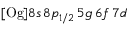Convert formula to latex. <formula><loc_0><loc_0><loc_500><loc_500>[ O g ] 8 s \, 8 p _ { 1 / 2 } \, 5 g \, 6 f \, 7 d</formula> 